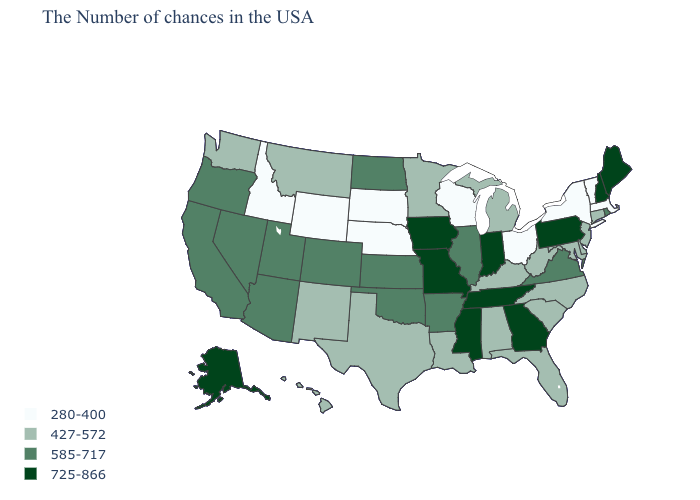Is the legend a continuous bar?
Write a very short answer. No. Which states hav the highest value in the West?
Give a very brief answer. Alaska. Does South Dakota have the lowest value in the USA?
Keep it brief. Yes. What is the value of Minnesota?
Short answer required. 427-572. Does Missouri have a higher value than Georgia?
Keep it brief. No. What is the value of Virginia?
Keep it brief. 585-717. What is the value of Illinois?
Quick response, please. 585-717. What is the lowest value in states that border Connecticut?
Give a very brief answer. 280-400. What is the value of Iowa?
Concise answer only. 725-866. What is the highest value in the South ?
Short answer required. 725-866. What is the highest value in states that border Colorado?
Quick response, please. 585-717. What is the value of Missouri?
Answer briefly. 725-866. What is the value of Idaho?
Concise answer only. 280-400. Name the states that have a value in the range 725-866?
Short answer required. Maine, New Hampshire, Pennsylvania, Georgia, Indiana, Tennessee, Mississippi, Missouri, Iowa, Alaska. What is the value of Kentucky?
Quick response, please. 427-572. 